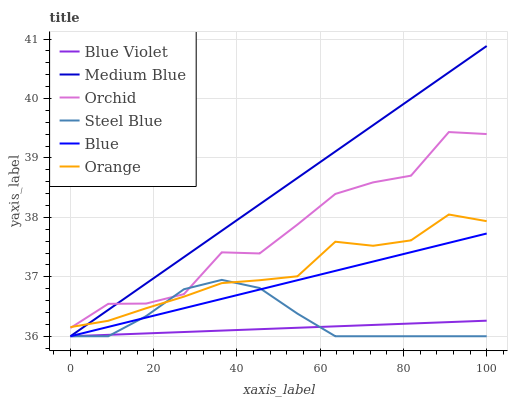Does Blue Violet have the minimum area under the curve?
Answer yes or no. Yes. Does Medium Blue have the maximum area under the curve?
Answer yes or no. Yes. Does Steel Blue have the minimum area under the curve?
Answer yes or no. No. Does Steel Blue have the maximum area under the curve?
Answer yes or no. No. Is Blue Violet the smoothest?
Answer yes or no. Yes. Is Orchid the roughest?
Answer yes or no. Yes. Is Medium Blue the smoothest?
Answer yes or no. No. Is Medium Blue the roughest?
Answer yes or no. No. Does Blue have the lowest value?
Answer yes or no. Yes. Does Orange have the lowest value?
Answer yes or no. No. Does Medium Blue have the highest value?
Answer yes or no. Yes. Does Steel Blue have the highest value?
Answer yes or no. No. Is Blue Violet less than Orchid?
Answer yes or no. Yes. Is Orchid greater than Blue Violet?
Answer yes or no. Yes. Does Orange intersect Steel Blue?
Answer yes or no. Yes. Is Orange less than Steel Blue?
Answer yes or no. No. Is Orange greater than Steel Blue?
Answer yes or no. No. Does Blue Violet intersect Orchid?
Answer yes or no. No. 